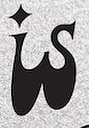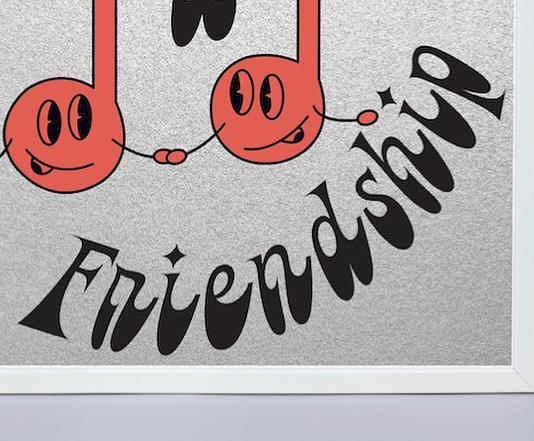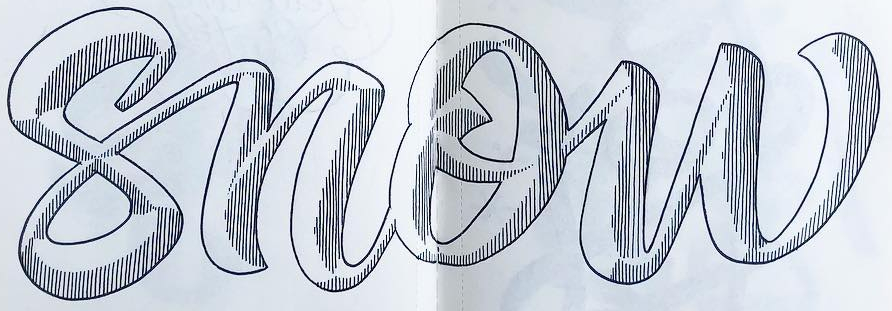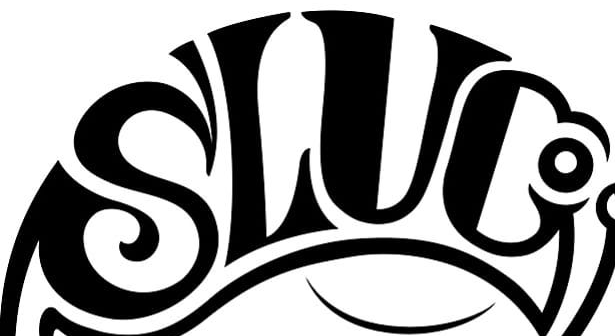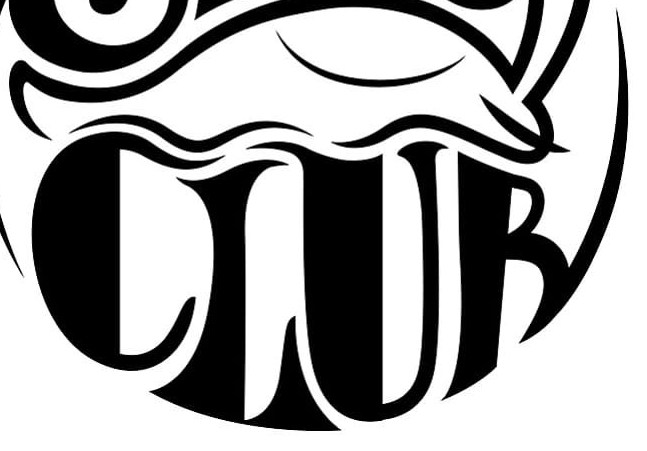Transcribe the words shown in these images in order, separated by a semicolon. is; Friendship; snow; SLUC; CLUB 